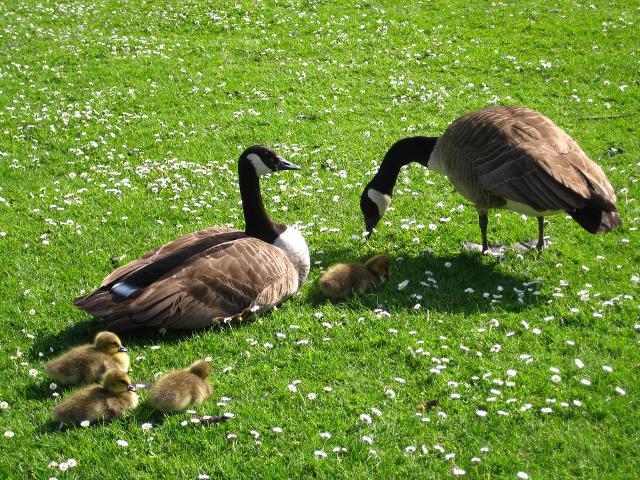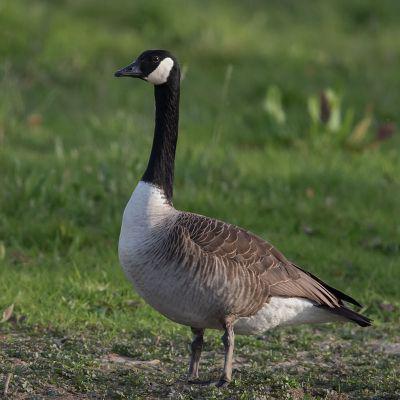The first image is the image on the left, the second image is the image on the right. Analyze the images presented: Is the assertion "there are two ducks in the right image." valid? Answer yes or no. No. The first image is the image on the left, the second image is the image on the right. Analyze the images presented: Is the assertion "An image shows two adult geese on a grassy field with multiple goslings." valid? Answer yes or no. Yes. 